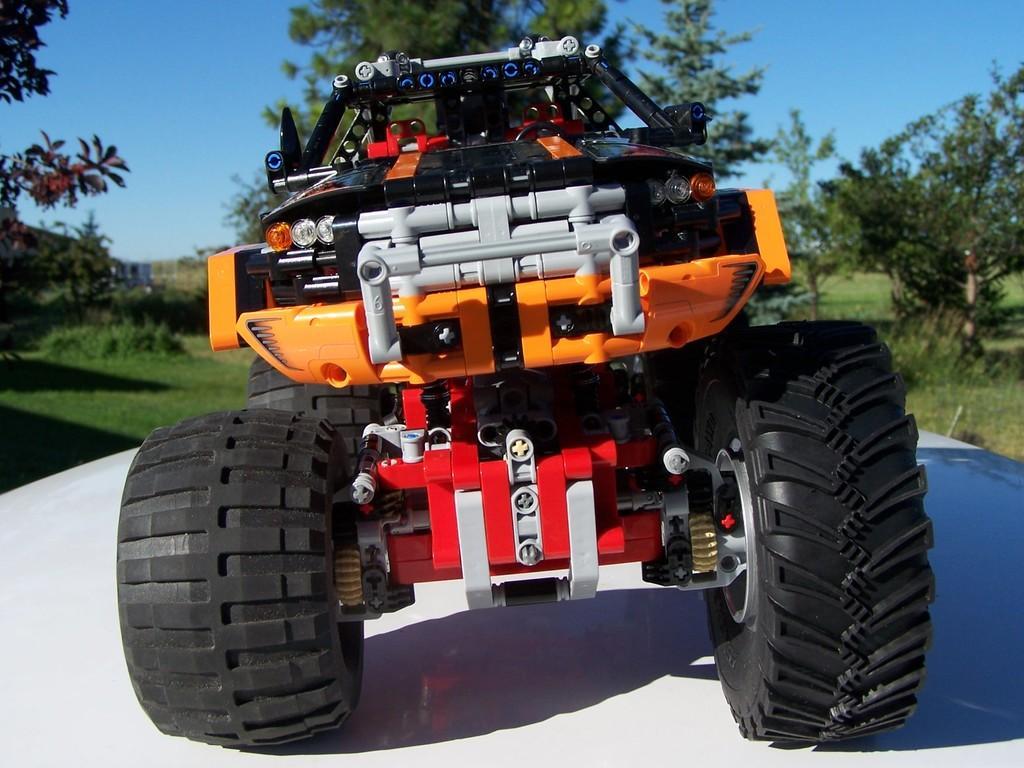Please provide a concise description of this image. In this image I can see a toy vehicle on a white surface. In the background there are many trees and also I can see the grass. At the top of the image I can see the sky in blue color. 